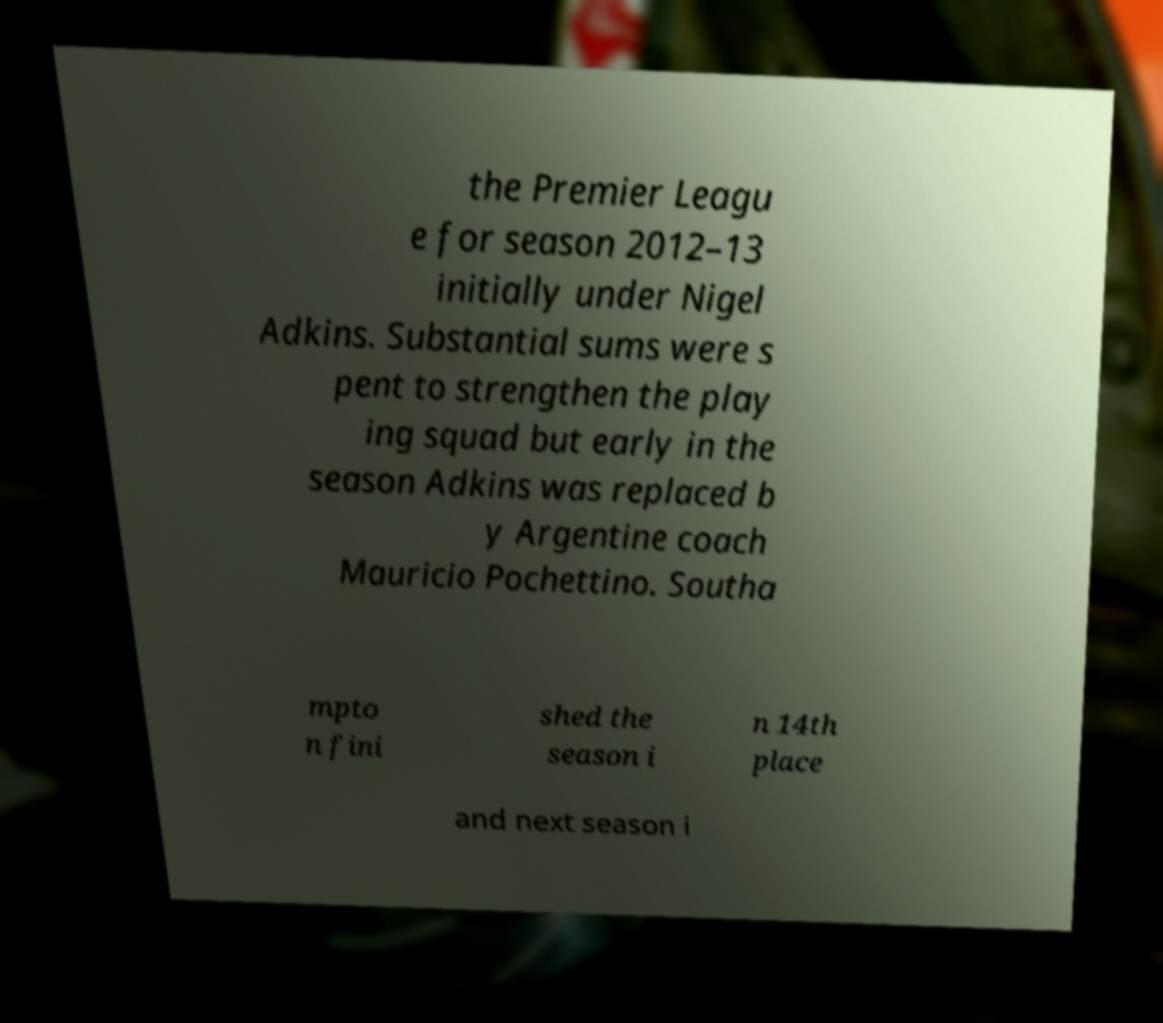Can you accurately transcribe the text from the provided image for me? the Premier Leagu e for season 2012–13 initially under Nigel Adkins. Substantial sums were s pent to strengthen the play ing squad but early in the season Adkins was replaced b y Argentine coach Mauricio Pochettino. Southa mpto n fini shed the season i n 14th place and next season i 